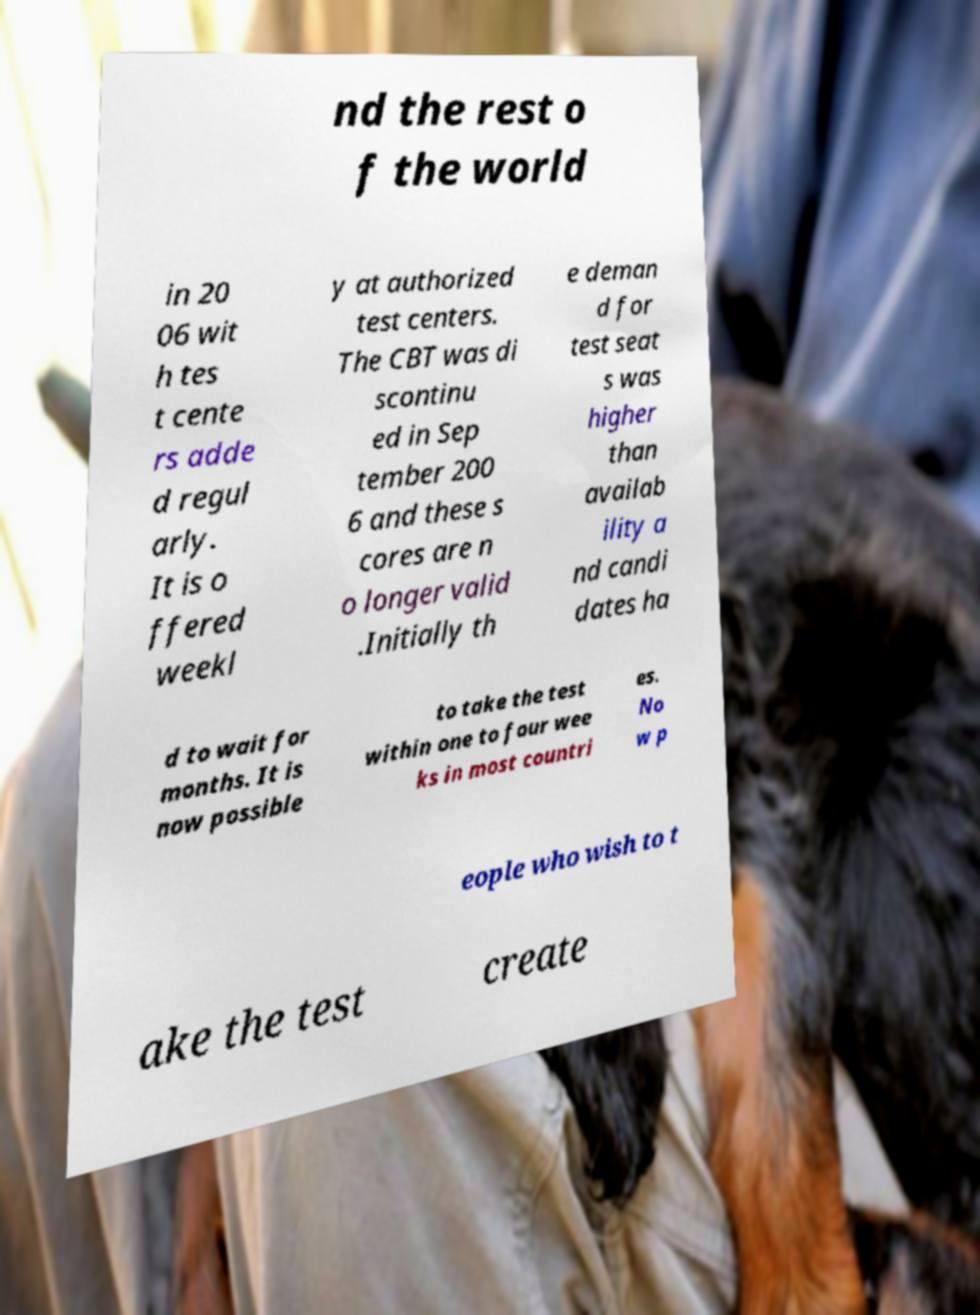Could you extract and type out the text from this image? nd the rest o f the world in 20 06 wit h tes t cente rs adde d regul arly. It is o ffered weekl y at authorized test centers. The CBT was di scontinu ed in Sep tember 200 6 and these s cores are n o longer valid .Initially th e deman d for test seat s was higher than availab ility a nd candi dates ha d to wait for months. It is now possible to take the test within one to four wee ks in most countri es. No w p eople who wish to t ake the test create 